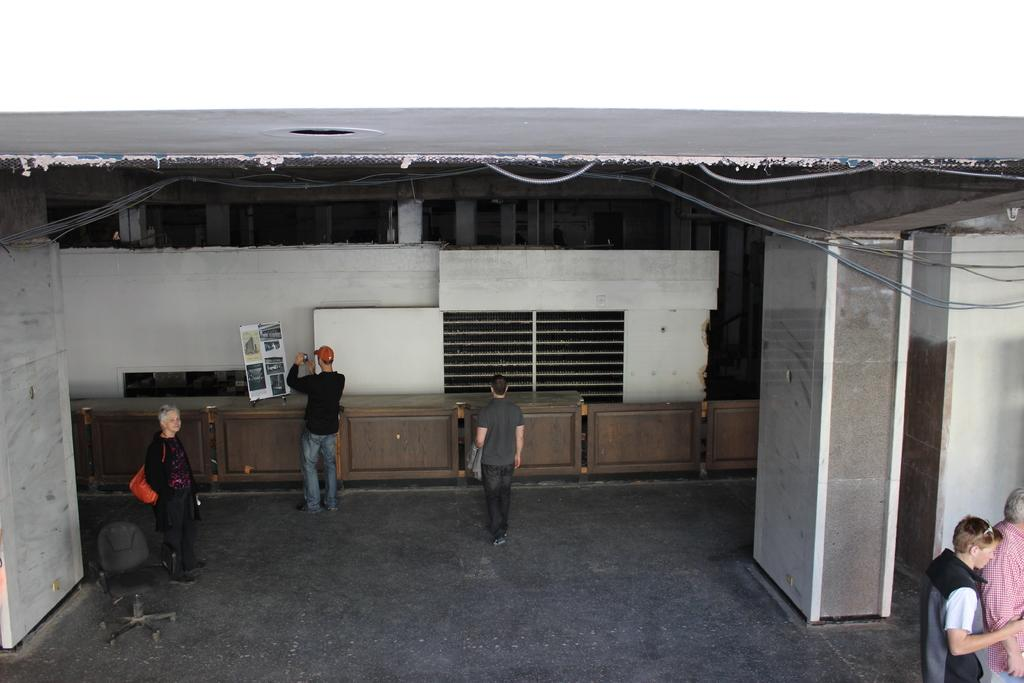What can be seen in the image? the image? There are people standing in the image. Where are the people standing? The people are standing on the floor. What can be seen in the distance in the image? There is a building in the background of the image. What type of joke can be heard being told by the people in the image? There is no indication in the image that the people are telling a joke, so it cannot be determined from the picture. 